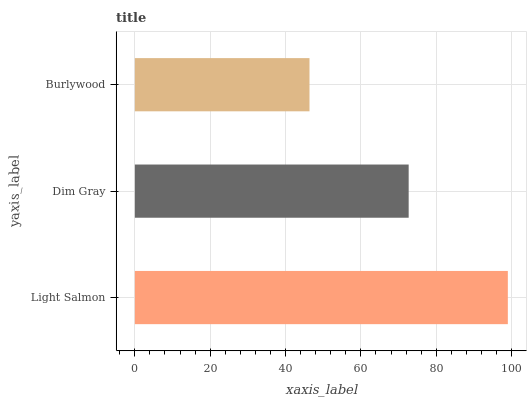Is Burlywood the minimum?
Answer yes or no. Yes. Is Light Salmon the maximum?
Answer yes or no. Yes. Is Dim Gray the minimum?
Answer yes or no. No. Is Dim Gray the maximum?
Answer yes or no. No. Is Light Salmon greater than Dim Gray?
Answer yes or no. Yes. Is Dim Gray less than Light Salmon?
Answer yes or no. Yes. Is Dim Gray greater than Light Salmon?
Answer yes or no. No. Is Light Salmon less than Dim Gray?
Answer yes or no. No. Is Dim Gray the high median?
Answer yes or no. Yes. Is Dim Gray the low median?
Answer yes or no. Yes. Is Light Salmon the high median?
Answer yes or no. No. Is Burlywood the low median?
Answer yes or no. No. 